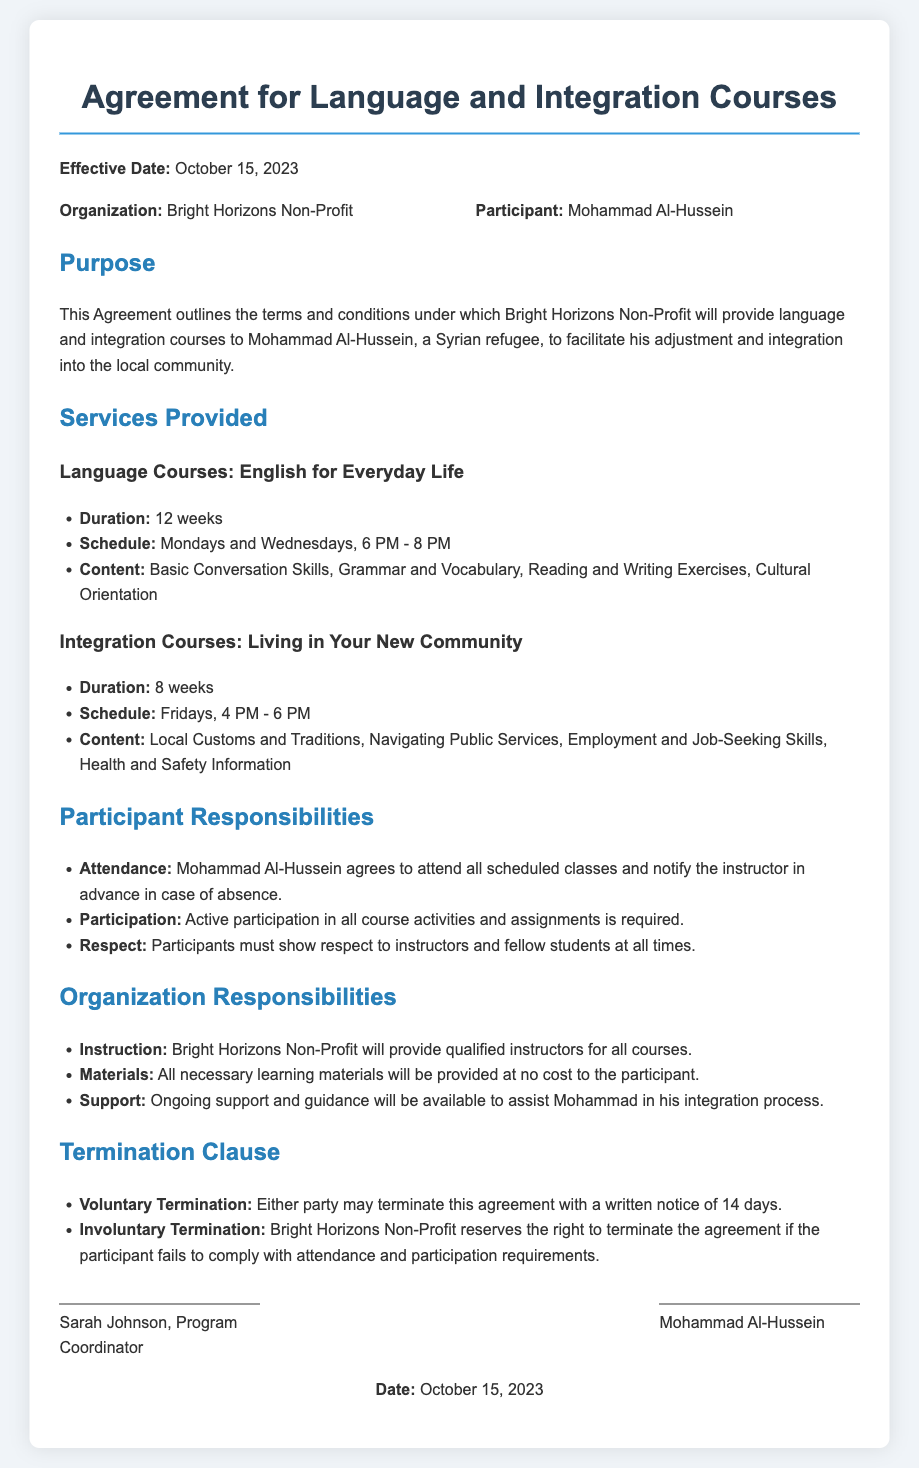What is the effective date of the agreement? The effective date is mentioned at the beginning of the document.
Answer: October 15, 2023 Who is the participant in this agreement? The participant's name is specified in the parties section of the document.
Answer: Mohammad Al-Hussein How long is the language course? The duration is listed under the services provided section for language courses.
Answer: 12 weeks What are the scheduled days for the language courses? The schedule is provided in the language courses section of the document.
Answer: Mondays and Wednesdays What is the main purpose of this agreement? The purpose is summarized in the purpose section at the outset of the document.
Answer: Facilitate adjustment and integration What is required for termination of the agreement? The termination clause outlines the notice requirements for both parties.
Answer: Written notice of 14 days What type of support is provided by the organization? This information is found in the organization responsibilities section regarding ongoing assistance.
Answer: Ongoing support and guidance What content is covered in the integration courses? The specific topics are listed under the integration courses section of the document.
Answer: Local Customs and Traditions, Navigating Public Services, Employment and Job-Seeking Skills, Health and Safety Information What must participants show to instructors and fellow students? This requirement is noted in the participant responsibilities section.
Answer: Respect 